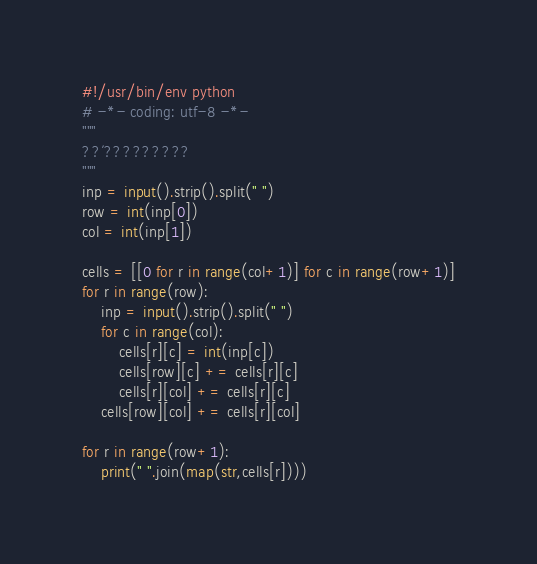Convert code to text. <code><loc_0><loc_0><loc_500><loc_500><_Python_>#!/usr/bin/env python
# -*- coding: utf-8 -*-
"""
??´?????????
"""
inp = input().strip().split(" ")
row = int(inp[0])
col = int(inp[1])

cells = [[0 for r in range(col+1)] for c in range(row+1)]
for r in range(row):
    inp = input().strip().split(" ")
    for c in range(col):
        cells[r][c] = int(inp[c])
        cells[row][c] += cells[r][c]
        cells[r][col] += cells[r][c]
    cells[row][col] += cells[r][col]

for r in range(row+1):
    print(" ".join(map(str,cells[r])))</code> 